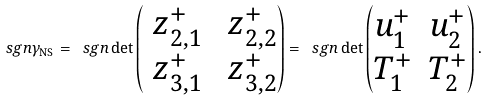<formula> <loc_0><loc_0><loc_500><loc_500>\ s g n \gamma _ { \text {NS} } = \ s g n \det \begin{pmatrix} \ z _ { 2 , 1 } ^ { + } & \ z _ { 2 , 2 } ^ { + } \\ \ z _ { 3 , 1 } ^ { + } & \ z _ { 3 , 2 } ^ { + } \end{pmatrix} = \ s g n \det \begin{pmatrix} u _ { 1 } ^ { + } & u _ { 2 } ^ { + } \\ T _ { 1 } ^ { + } & T _ { 2 } ^ { + } \end{pmatrix} .</formula> 